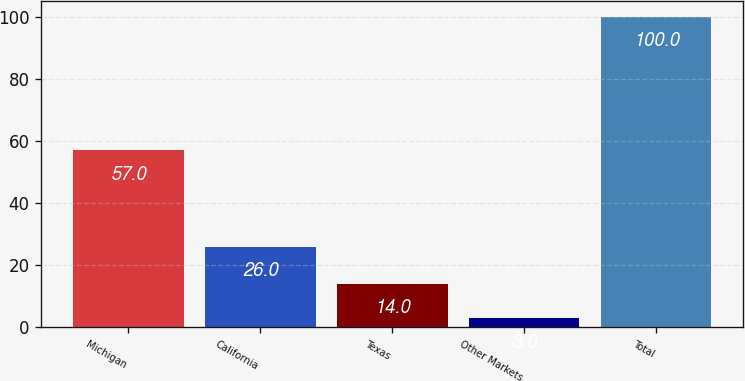<chart> <loc_0><loc_0><loc_500><loc_500><bar_chart><fcel>Michigan<fcel>California<fcel>Texas<fcel>Other Markets<fcel>Total<nl><fcel>57<fcel>26<fcel>14<fcel>3<fcel>100<nl></chart> 